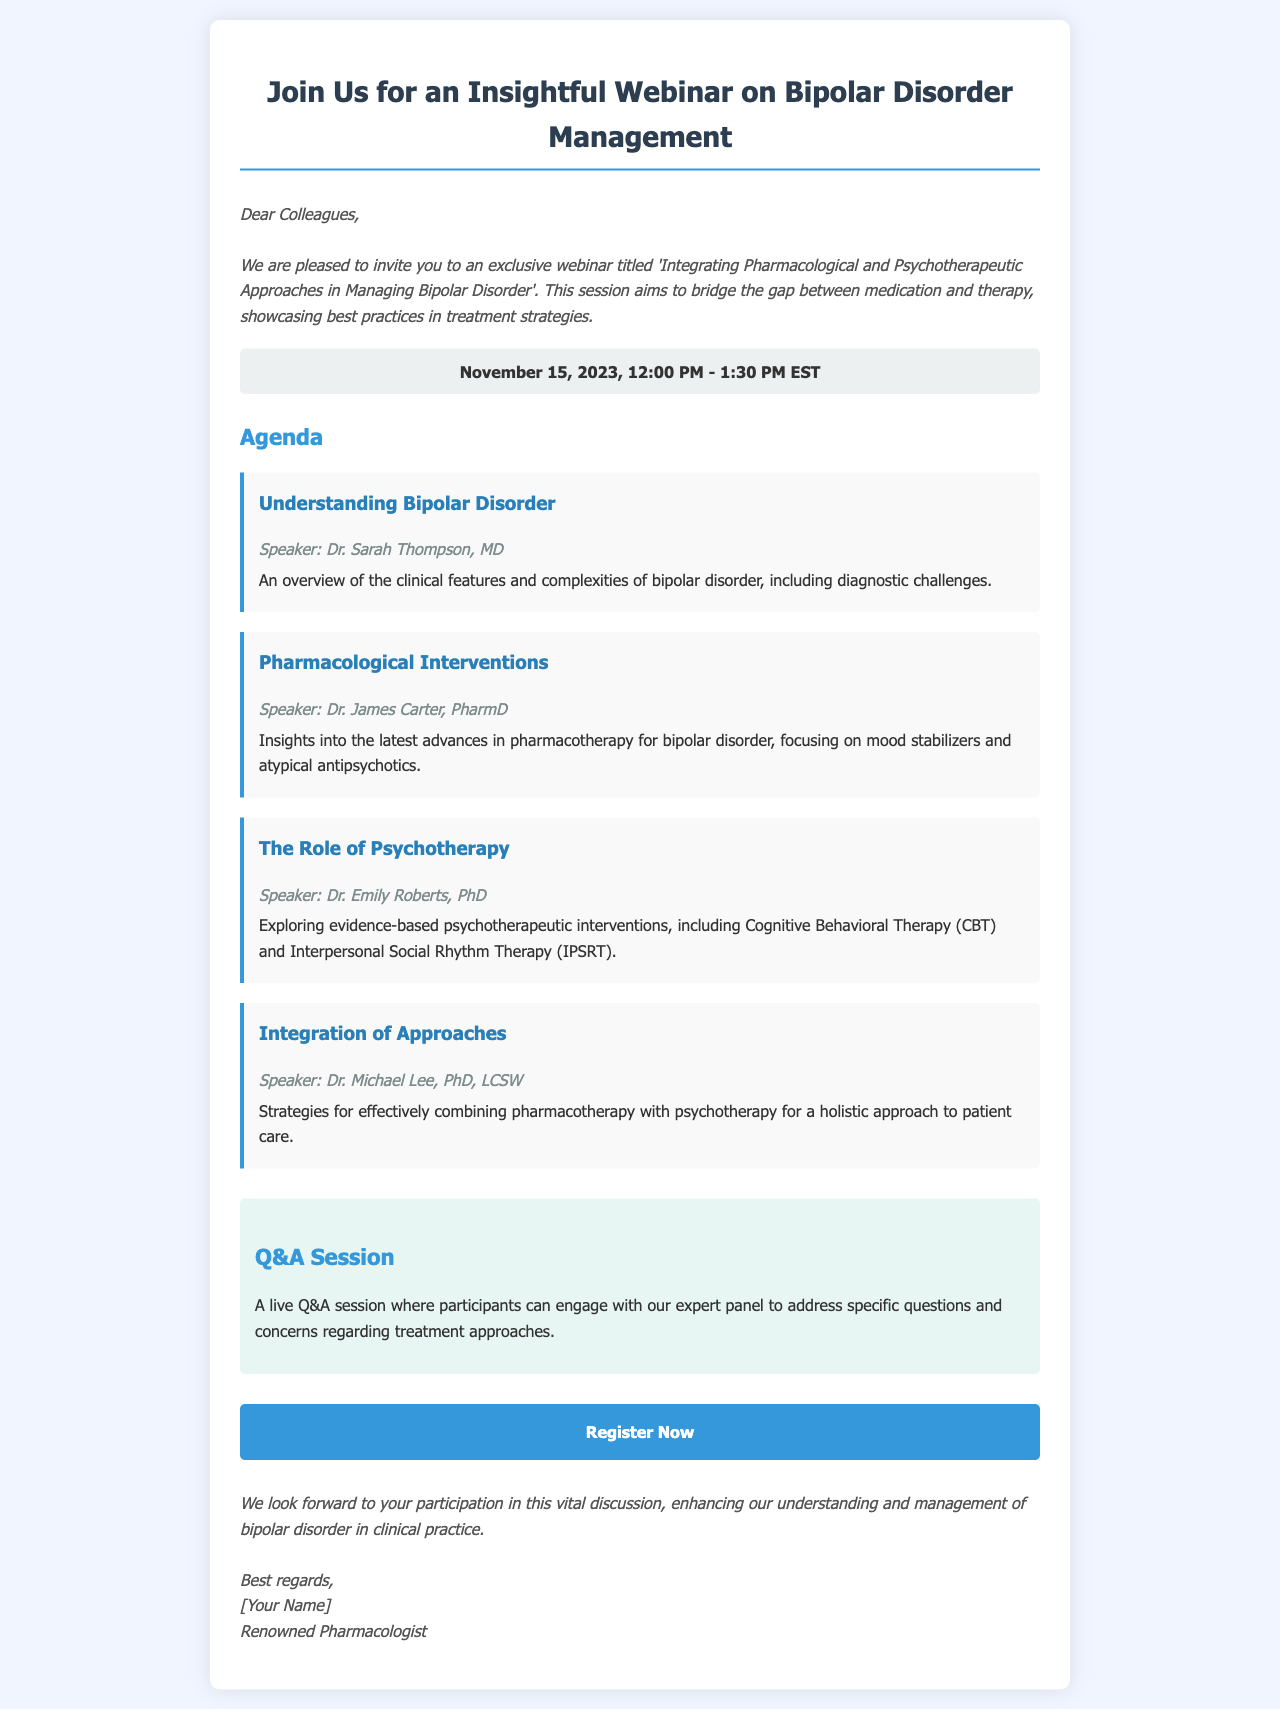What is the title of the webinar? The title of the webinar is clearly stated at the beginning of the document as 'Integrating Pharmacological and Psychotherapeutic Approaches in Managing Bipolar Disorder'.
Answer: Integrating Pharmacological and Psychotherapeutic Approaches in Managing Bipolar Disorder Who is the speaker for the session on pharmacological interventions? The document lists Dr. James Carter, PharmD as the speaker for the pharmacological interventions session.
Answer: Dr. James Carter, PharmD What is the date and time of the webinar? The date and time of the webinar is provided in a dedicated section as November 15, 2023, 12:00 PM - 1:30 PM EST.
Answer: November 15, 2023, 12:00 PM - 1:30 PM EST What is the agenda item that discusses evidence-based psychotherapeutic interventions? The document mentions 'The Role of Psychotherapy' as the agenda item that explores evidence-based psychotherapeutic interventions.
Answer: The Role of Psychotherapy What type of session will be held after the presentations? The document indicates a live Q&A session where participants can engage with the expert panel.
Answer: Q&A Session Which approach is emphasized for patient care in the integration strategies? The document highlights the importance of combining pharmacotherapy with psychotherapy for a holistic approach to patient care.
Answer: Combining pharmacotherapy with psychotherapy What is the primary purpose of the webinar? The document specifies that the session aims to bridge the gap between medication and therapy, showcasing best practices in treatment strategies.
Answer: Bridge the gap between medication and therapy Where can participants register for the webinar? A registration link is provided in the document directing participants to register for the webinar, specifically at 'https://example.com/webinar-registration'.
Answer: https://example.com/webinar-registration 